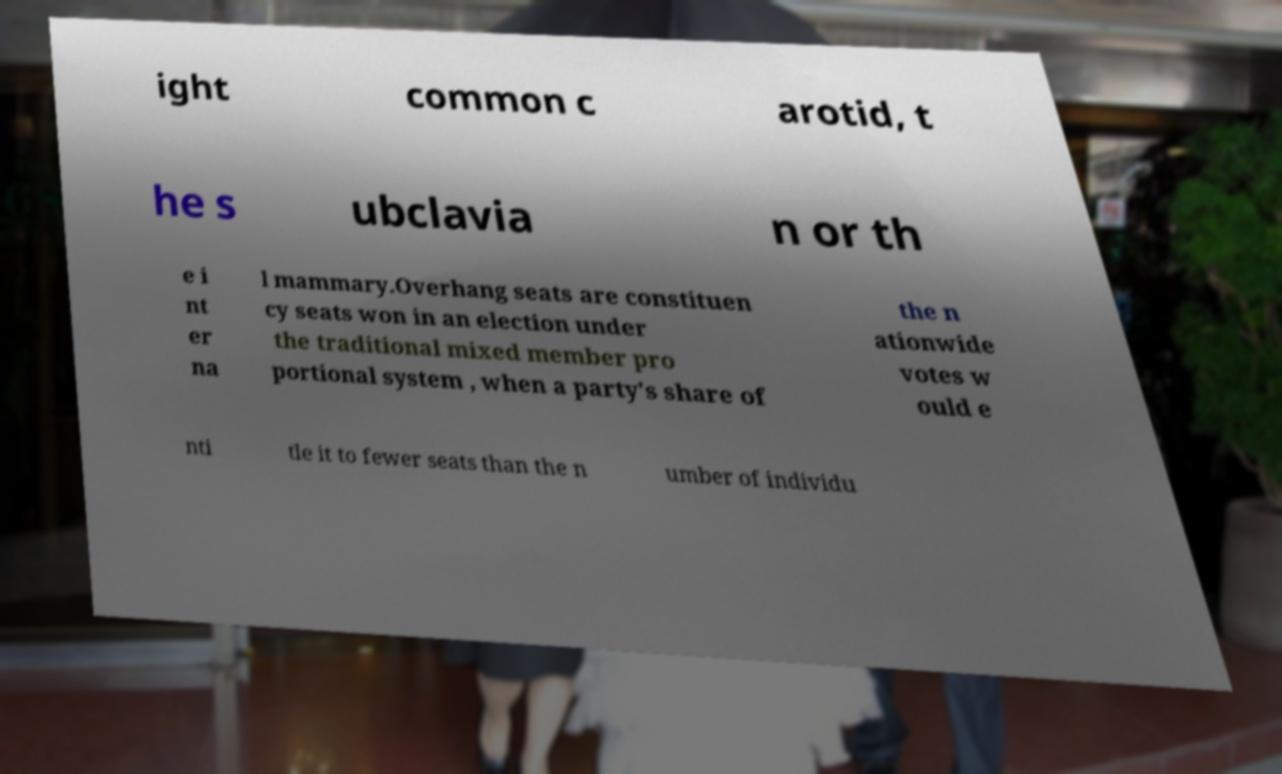Can you accurately transcribe the text from the provided image for me? ight common c arotid, t he s ubclavia n or th e i nt er na l mammary.Overhang seats are constituen cy seats won in an election under the traditional mixed member pro portional system , when a party's share of the n ationwide votes w ould e nti tle it to fewer seats than the n umber of individu 